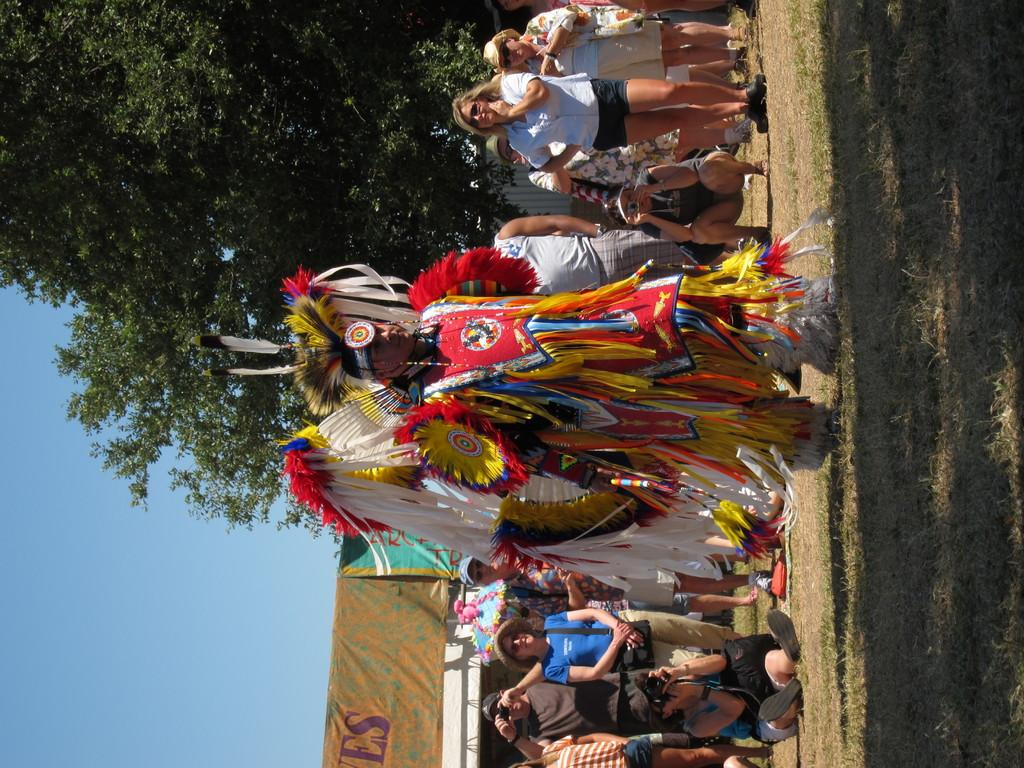What are the people in the image doing? Some of the people in the image are clicking pictures. Can you describe the man's attire in the image? A man is wearing a fancy costume in the image. What can be seen in the background of the image? There is a tree, banners, and the sky visible in the background of the image. What type of music is the band playing in the background of the image? There is no band present in the image, so it is not possible to determine what type of music might be playing. 